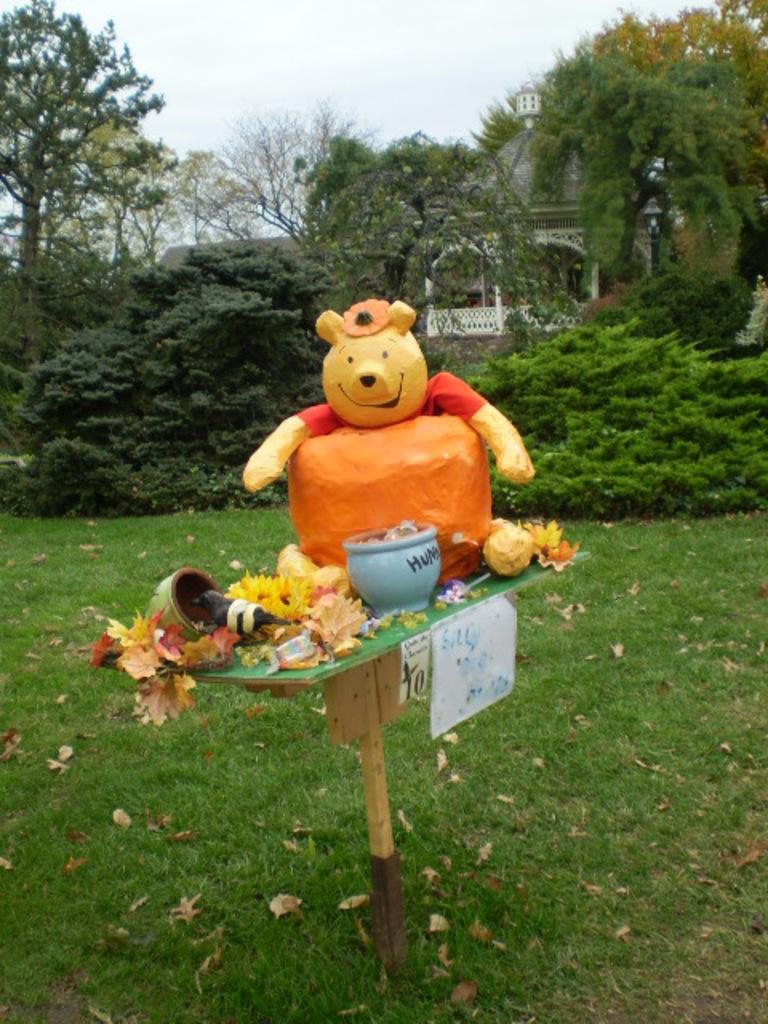What is the main subject of the image? There is a statue of a teddy bear in the image. What decorations are present around the statue? The statue has flowers around it. What is placed in front of the statue? There is a bowl in front of the statue. Where is the statue located? The statue is on a grassland. What can be seen in the background of the image? There are trees and a building visible in the background. What is visible above the statue? The sky is visible above the statue. What type of lace is draped over the statue in the image? There is no lace present in the image; the statue has flowers around it. How many knives are visible in the image? There are no knives present in the image. 